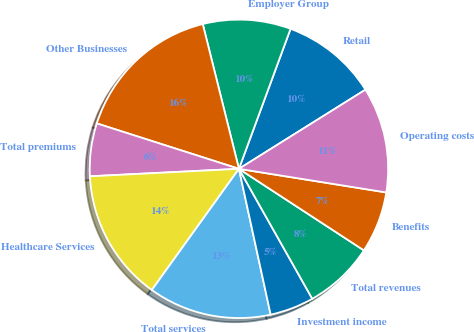<chart> <loc_0><loc_0><loc_500><loc_500><pie_chart><fcel>Retail<fcel>Employer Group<fcel>Other Businesses<fcel>Total premiums<fcel>Healthcare Services<fcel>Total services<fcel>Investment income<fcel>Total revenues<fcel>Benefits<fcel>Operating costs<nl><fcel>10.48%<fcel>9.52%<fcel>16.18%<fcel>5.72%<fcel>14.28%<fcel>13.33%<fcel>4.77%<fcel>7.62%<fcel>6.67%<fcel>11.43%<nl></chart> 